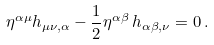<formula> <loc_0><loc_0><loc_500><loc_500>\eta ^ { \alpha \mu } h _ { \mu \nu , \alpha } - \frac { 1 } { 2 } \eta ^ { \alpha \beta } \, h _ { \alpha \beta , \nu } = 0 \, .</formula> 